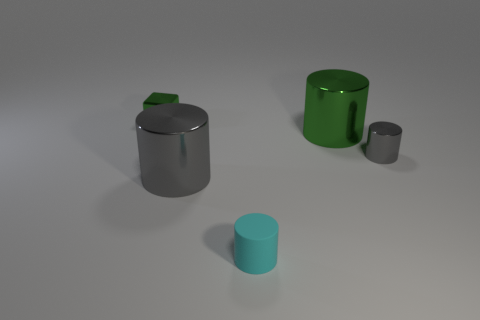Are there any visual cues about the setting of these objects? The cylinders are placed on a flat, neutral-tone surface with a soft shadow outlining each object, suggesting a diffuse light source overhead, creating a simple and controlled environment that might be used for product display or a design showcase. Is there anything unique about the smallest cylinder? The smallest cylinder displays a distinctive aqua color, contrasting with the other cylinders' more muted tones, and it lacks any apparent lid or opening, unlike the larger gray cylinder next to it. 